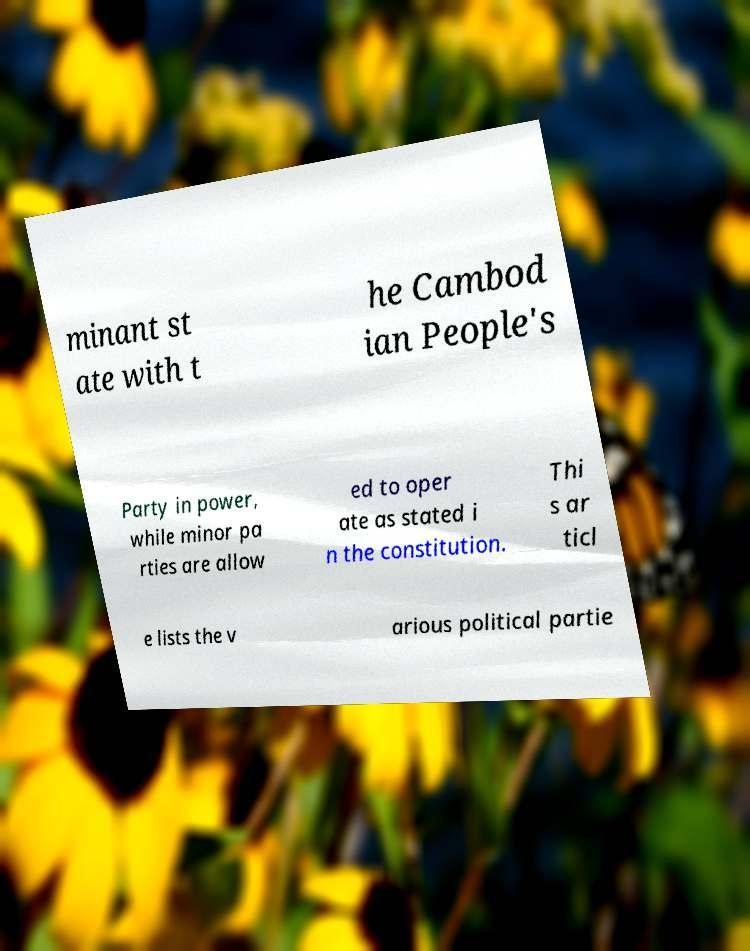Can you accurately transcribe the text from the provided image for me? minant st ate with t he Cambod ian People's Party in power, while minor pa rties are allow ed to oper ate as stated i n the constitution. Thi s ar ticl e lists the v arious political partie 